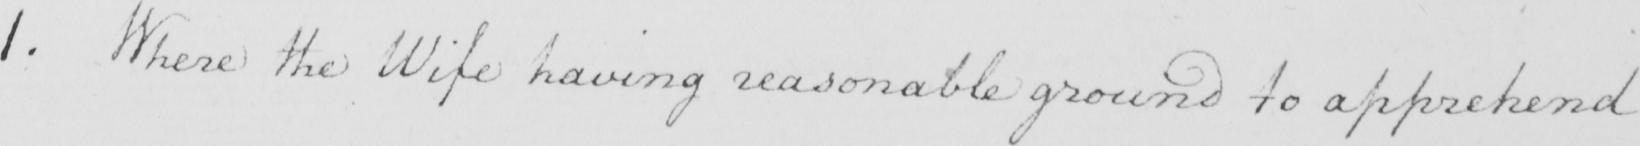Please transcribe the handwritten text in this image. 1 . Where the Wife having reasonable ground to apprehend 